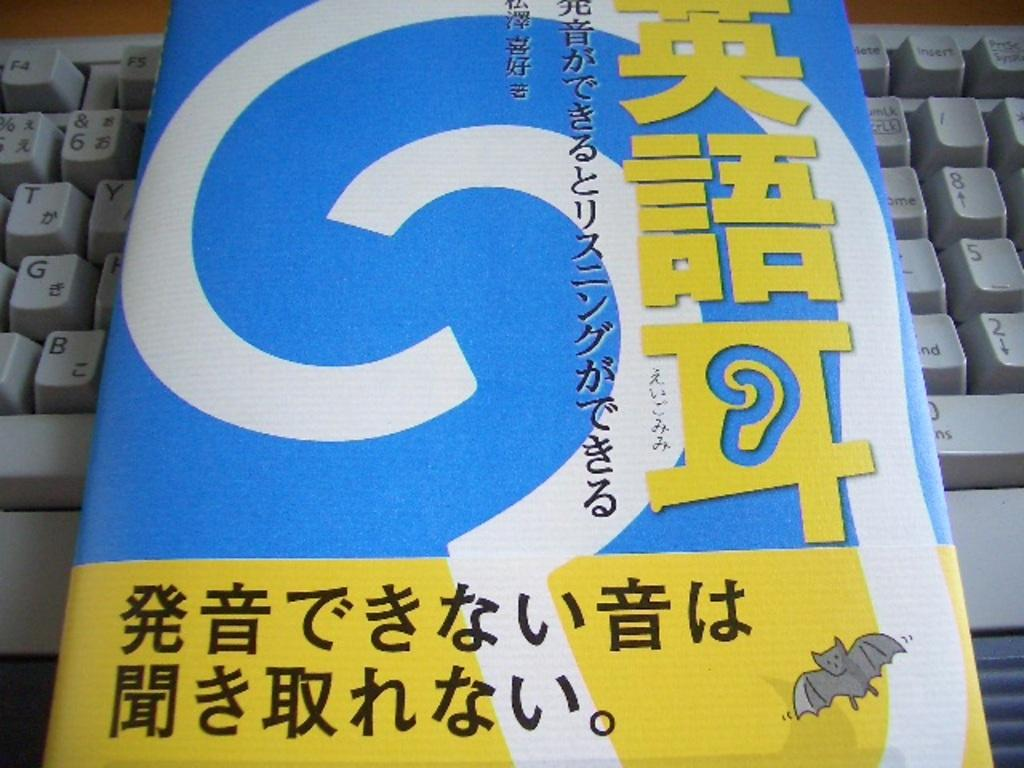<image>
Offer a succinct explanation of the picture presented. A book placed on a computer keyboard so that the only visible function keys are F4 and F5. 